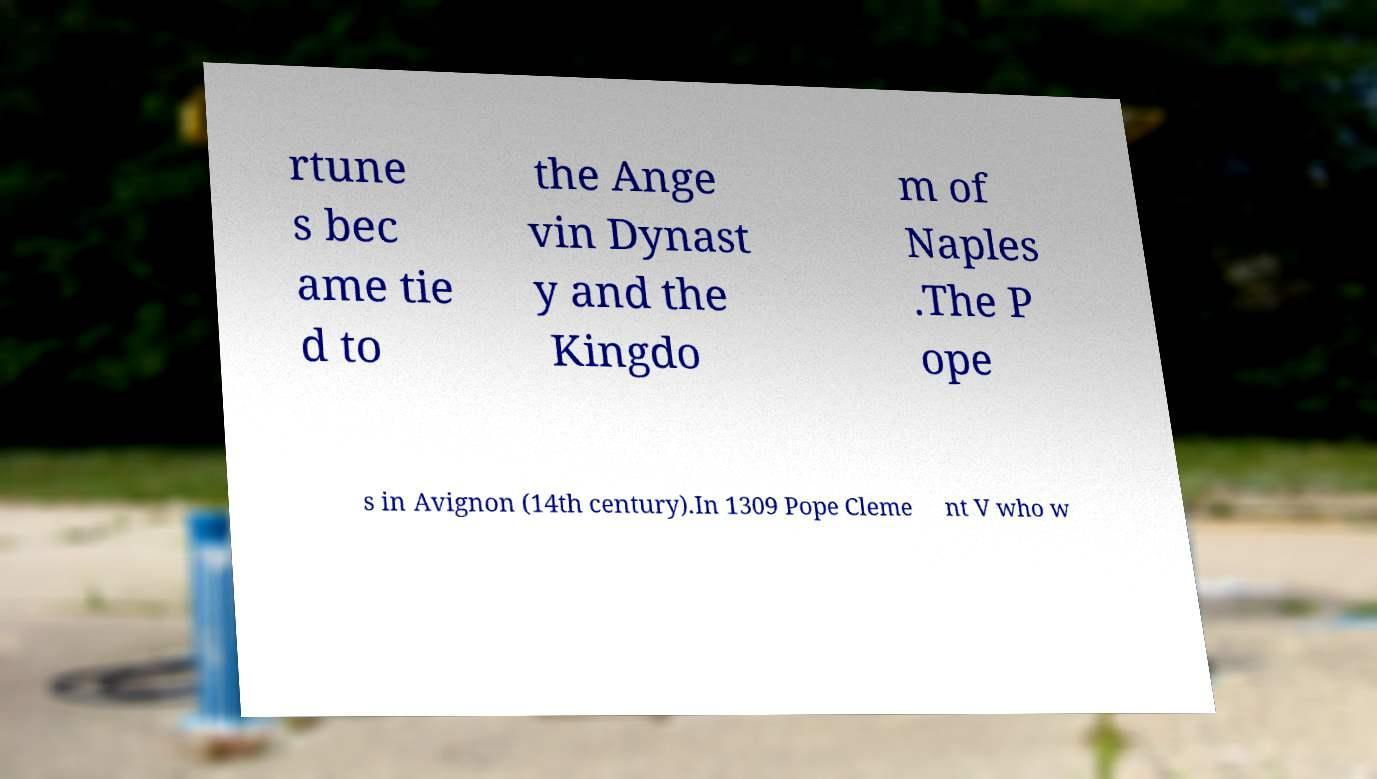I need the written content from this picture converted into text. Can you do that? rtune s bec ame tie d to the Ange vin Dynast y and the Kingdo m of Naples .The P ope s in Avignon (14th century).In 1309 Pope Cleme nt V who w 